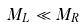<formula> <loc_0><loc_0><loc_500><loc_500>M _ { L } \ll M _ { R }</formula> 